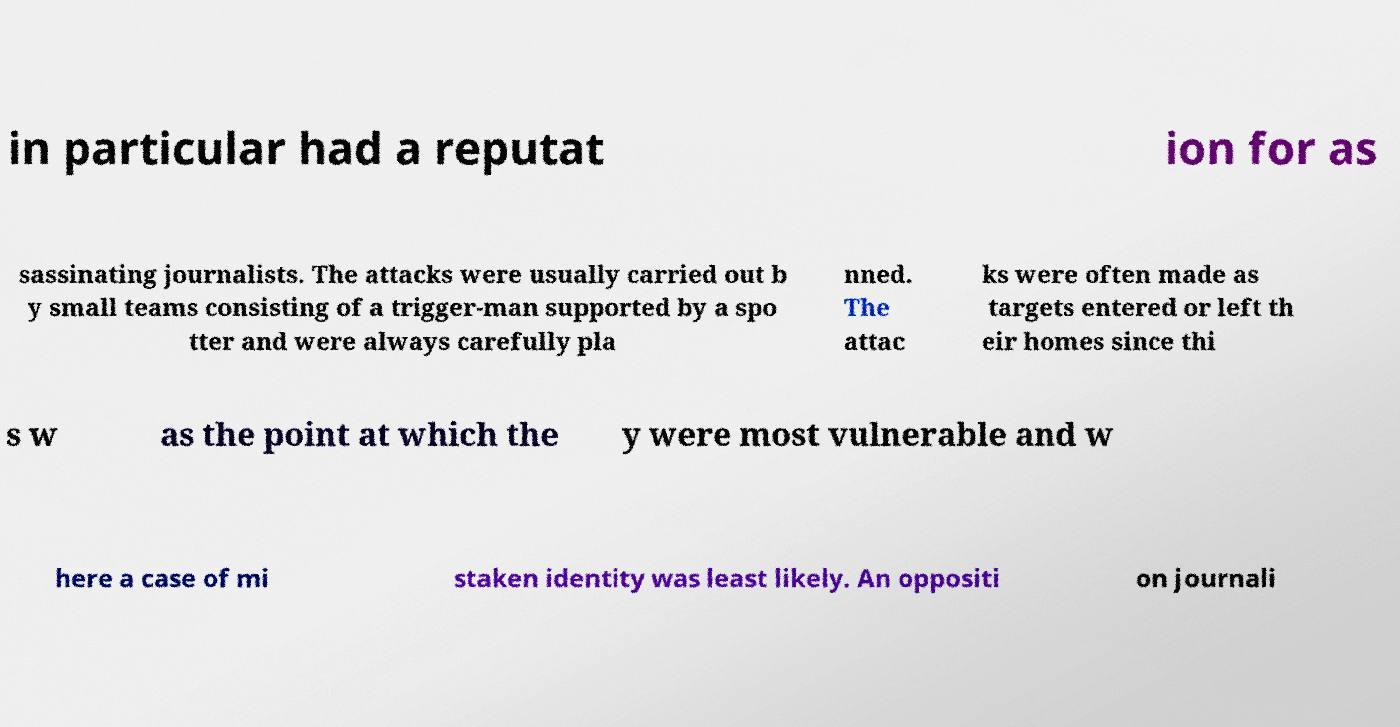Could you extract and type out the text from this image? in particular had a reputat ion for as sassinating journalists. The attacks were usually carried out b y small teams consisting of a trigger-man supported by a spo tter and were always carefully pla nned. The attac ks were often made as targets entered or left th eir homes since thi s w as the point at which the y were most vulnerable and w here a case of mi staken identity was least likely. An oppositi on journali 